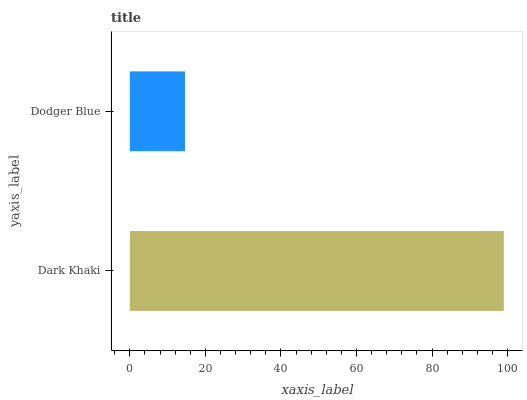Is Dodger Blue the minimum?
Answer yes or no. Yes. Is Dark Khaki the maximum?
Answer yes or no. Yes. Is Dodger Blue the maximum?
Answer yes or no. No. Is Dark Khaki greater than Dodger Blue?
Answer yes or no. Yes. Is Dodger Blue less than Dark Khaki?
Answer yes or no. Yes. Is Dodger Blue greater than Dark Khaki?
Answer yes or no. No. Is Dark Khaki less than Dodger Blue?
Answer yes or no. No. Is Dark Khaki the high median?
Answer yes or no. Yes. Is Dodger Blue the low median?
Answer yes or no. Yes. Is Dodger Blue the high median?
Answer yes or no. No. Is Dark Khaki the low median?
Answer yes or no. No. 